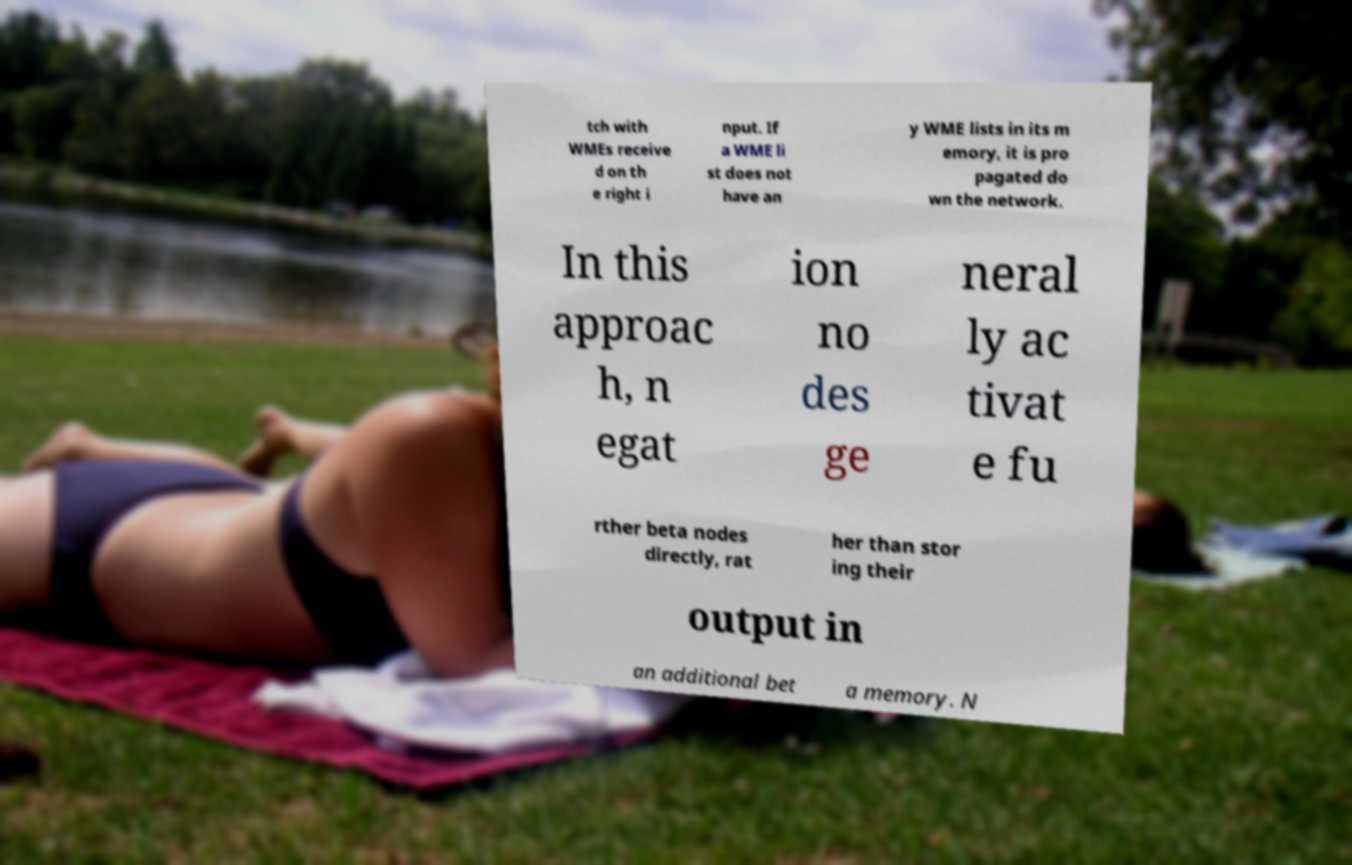There's text embedded in this image that I need extracted. Can you transcribe it verbatim? tch with WMEs receive d on th e right i nput. If a WME li st does not have an y WME lists in its m emory, it is pro pagated do wn the network. In this approac h, n egat ion no des ge neral ly ac tivat e fu rther beta nodes directly, rat her than stor ing their output in an additional bet a memory. N 